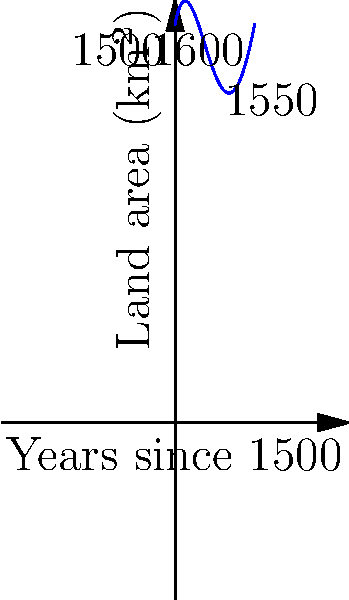The graph above represents the changing land area of Rantzau territories from 1500 to 1600 using a quartic polynomial. Based on this model, in which year did the Rantzau family's land holdings reach their peak, and what was the approximate maximum area? To solve this problem, we need to follow these steps:

1) The quartic polynomial is of the form $f(x) = -0.01x^4 + 0.3x^3 - 2.5x^2 + 5x + 50$, where $x$ represents years since 1500 and $f(x)$ represents land area in km².

2) To find the maximum point, we need to find where the derivative $f'(x)$ equals zero:

   $f'(x) = -0.04x^3 + 0.9x^2 - 5x + 5$

3) Setting $f'(x) = 0$ and solving this equation gives us $x \approx 4.2$.

4) This means the peak occurred about 4.2 years after 1500, which is approximately 1504.

5) To find the maximum area, we plug $x = 4.2$ into our original function:

   $f(4.2) \approx -0.01(4.2)^4 + 0.3(4.2)^3 - 2.5(4.2)^2 + 5(4.2) + 50 \approx 60.5$

Therefore, the Rantzau family's land holdings reached their peak around 1504, with a maximum area of approximately 60.5 km².
Answer: 1504, 60.5 km² 